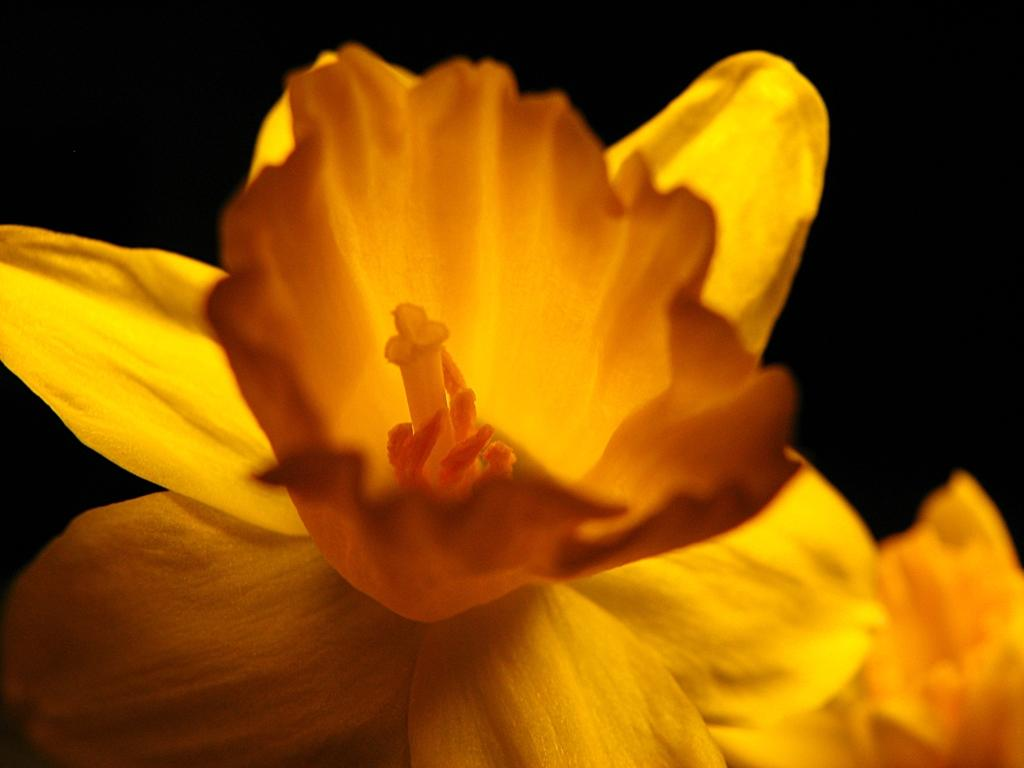What type of flower is in the image? There is a yellow flower in the image. Where is the flower located in the image? The flower is in the front of the image. What color can be seen in the background of the image? There is black color visible in the background of the image. Is there a servant holding a whip near the yellow flower in the image? No, there is no servant or whip present in the image. 